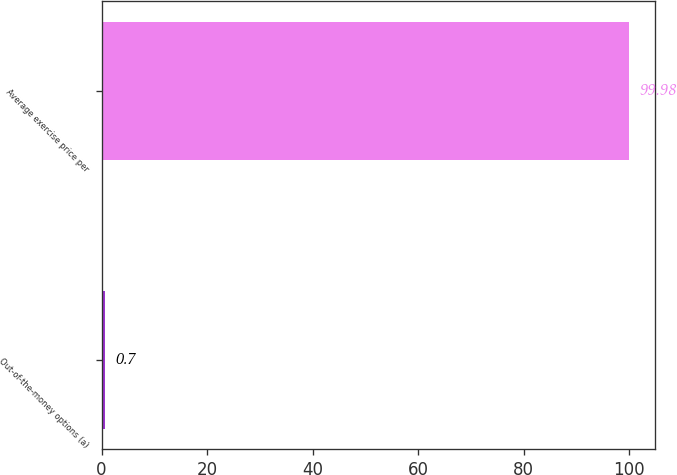Convert chart. <chart><loc_0><loc_0><loc_500><loc_500><bar_chart><fcel>Out-of-the-money options (a)<fcel>Average exercise price per<nl><fcel>0.7<fcel>99.98<nl></chart> 